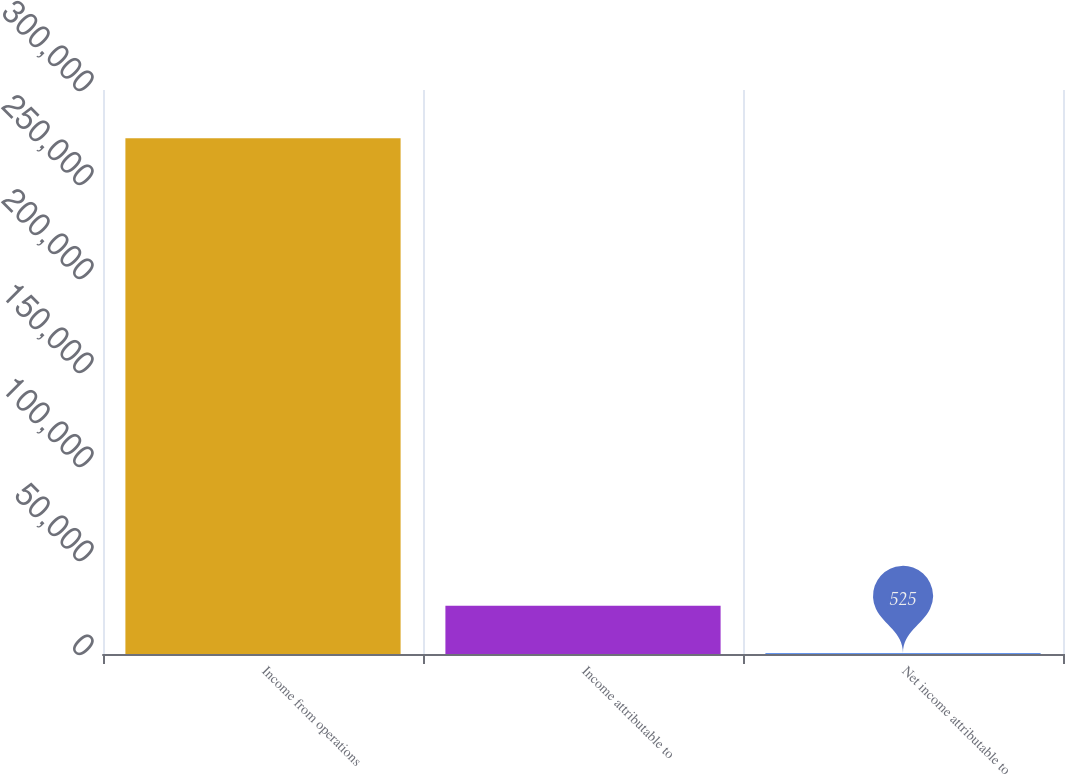Convert chart. <chart><loc_0><loc_0><loc_500><loc_500><bar_chart><fcel>Income from operations<fcel>Income attributable to<fcel>Net income attributable to<nl><fcel>274307<fcel>25705<fcel>525<nl></chart> 